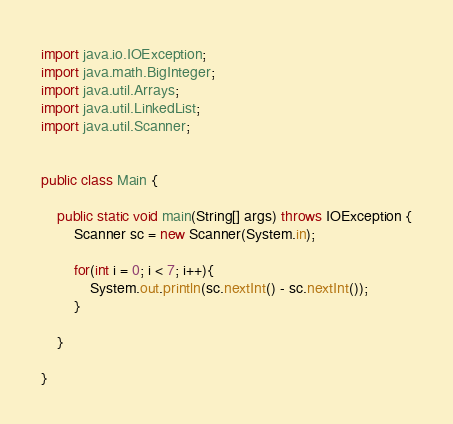<code> <loc_0><loc_0><loc_500><loc_500><_Java_>import java.io.IOException;
import java.math.BigInteger;
import java.util.Arrays;
import java.util.LinkedList;
import java.util.Scanner;


public class Main {
	
	public static void main(String[] args) throws IOException {
		Scanner sc = new Scanner(System.in);
		
		for(int i = 0; i < 7; i++){
			System.out.println(sc.nextInt() - sc.nextInt());
		}
		
	}

}</code> 